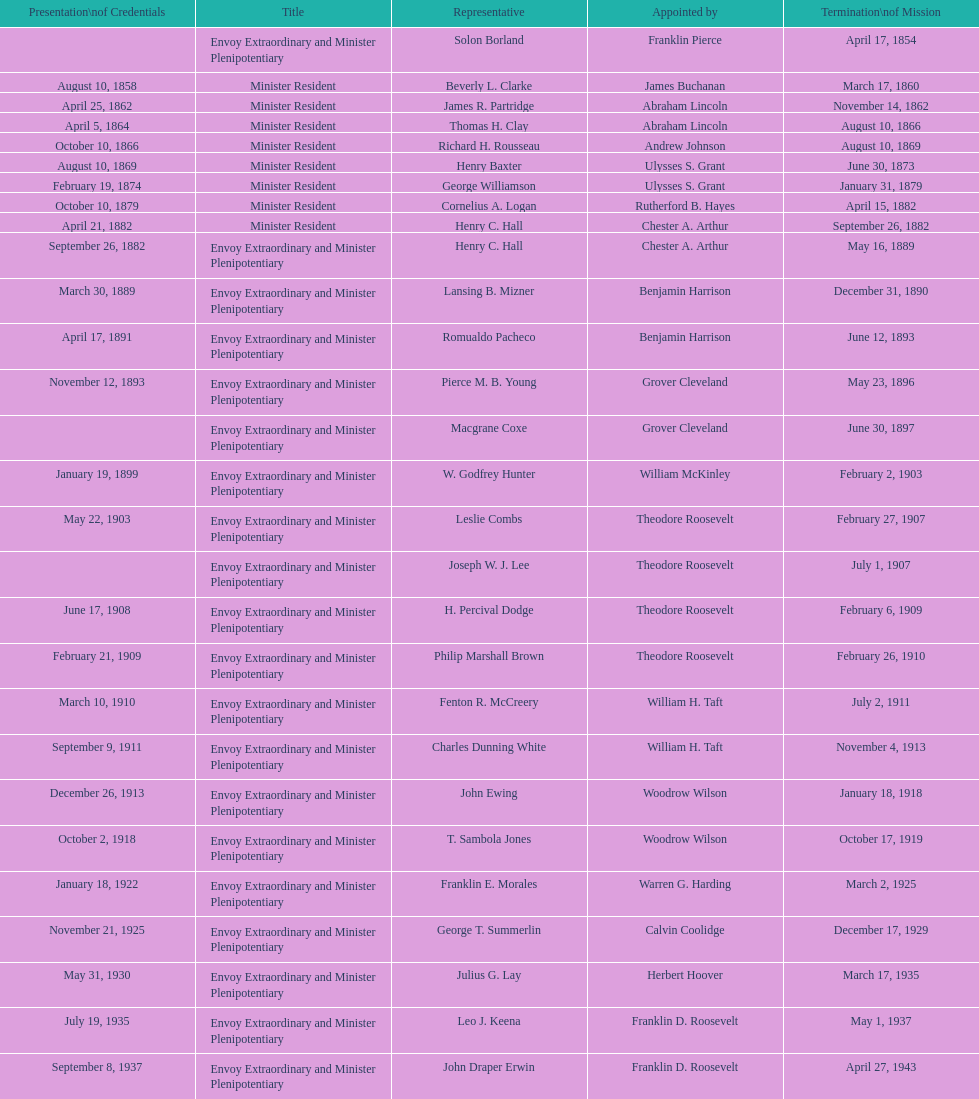What is the overall number of representatives that have existed? 50. 